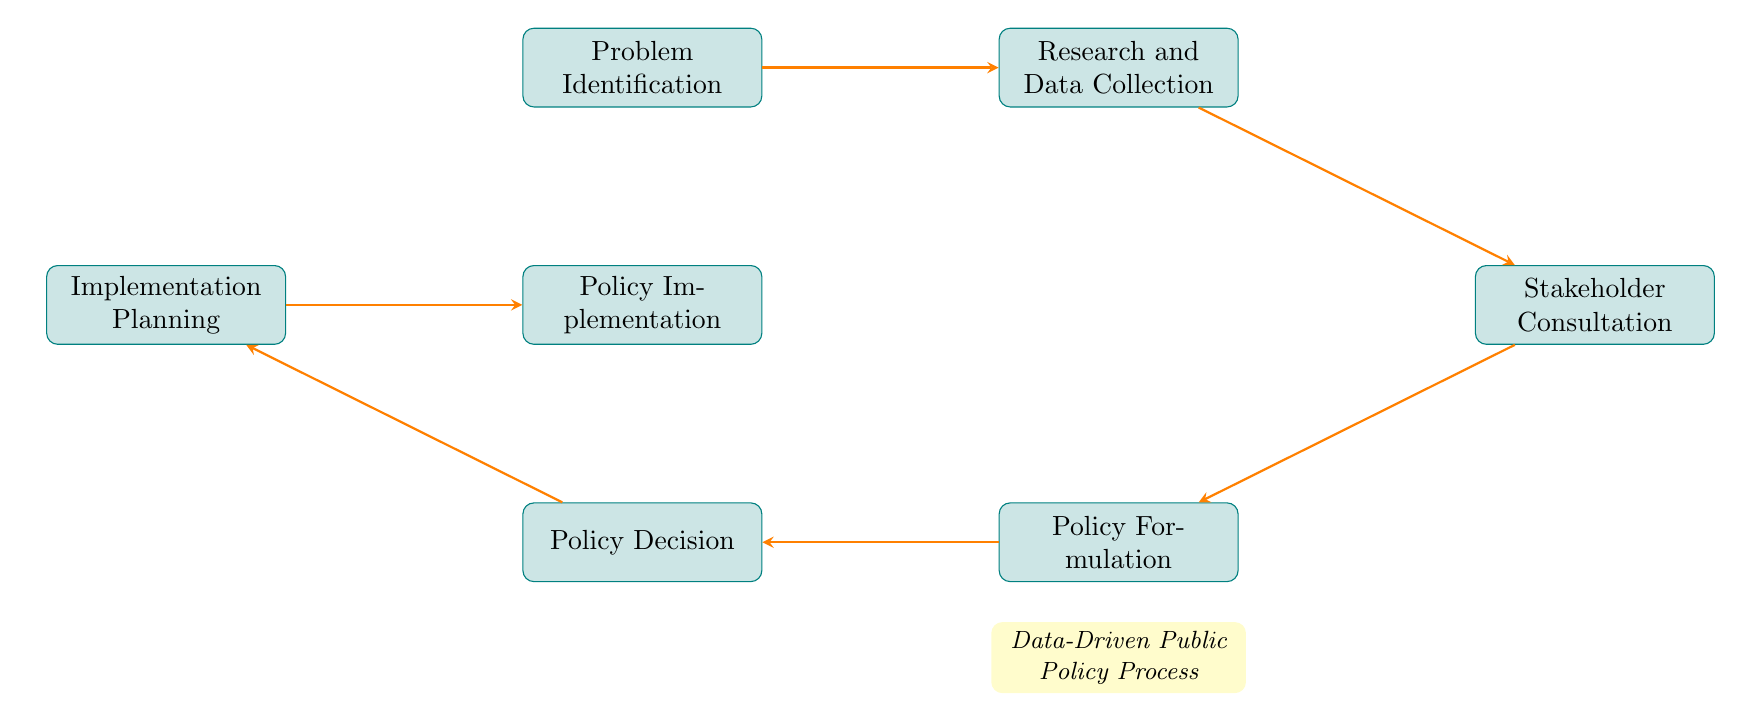What is the first step in the policy development process? The diagram shows that "Problem Identification" is the first step, as it is positioned at the top of the flow chart.
Answer: Problem Identification How many nodes are present in the diagram? By counting the individual steps listed in the flow chart, there are seven nodes representing different stages of the policy development process.
Answer: Seven Which step follows "Research and Data Collection"? The diagram indicates that "Stakeholder Consultation" comes directly after "Research and Data Collection", as shown by the arrow connecting the two nodes.
Answer: Stakeholder Consultation What process comes before "Policy Decision"? Looking at the flow of the diagram, "Policy Formulation" is the immediate step before "Policy Decision", indicated by the connecting arrow.
Answer: Policy Formulation What is indicated by the final node in the flow chart? The last node, "Policy Implementation", suggests that this is the last stage in the process after "Implementation Planning", where the policy is actually executed.
Answer: Policy Implementation Which node serves as a bridge between "Policy Decision" and "Implementation Planning"? The flowchart shows that "Implementation Planning" is the step that comes after "Policy Decision", hence it acts as a bridge to the subsequent node.
Answer: Implementation Planning How are the nodes connected, in terms of direction, across the diagram? The diagram consistently uses arrows pointing from one node to the next, indicating a sequential and unidirectional flow through the stages of policy development.
Answer: Unidirectional flow What is the primary focus of the process described in the diagram? The description below the flow chart specifies that the illustrated steps represent a "Data-Driven Public Policy Process", concentrating on base data and research.
Answer: Data-Driven Public Policy Process 